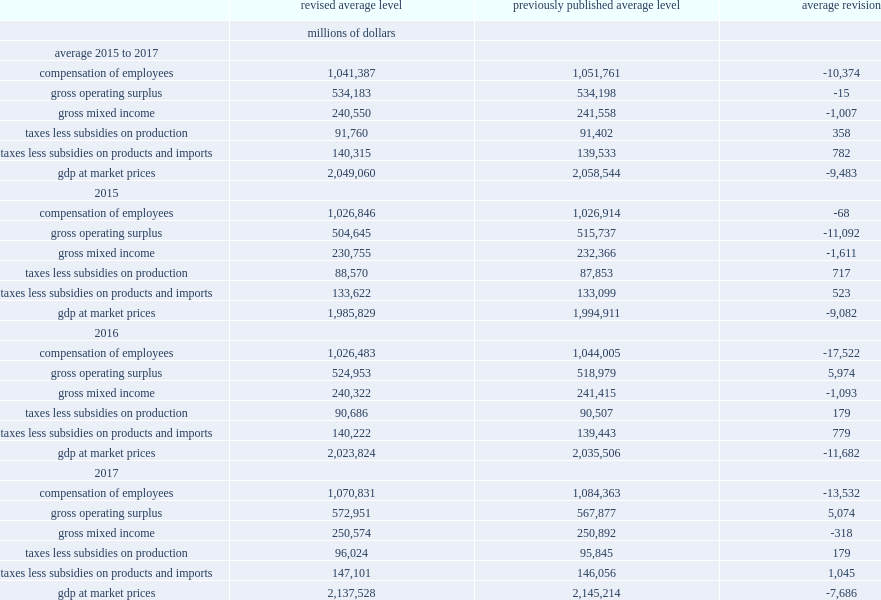Would you mind parsing the complete table? {'header': ['', 'revised average level', 'previously published average level', 'average revision'], 'rows': [['', 'millions of dollars', '', ''], ['average 2015 to 2017', '', '', ''], ['compensation of employees', '1,041,387', '1,051,761', '-10,374'], ['gross operating surplus', '534,183', '534,198', '-15'], ['gross mixed income', '240,550', '241,558', '-1,007'], ['taxes less subsidies on production', '91,760', '91,402', '358'], ['taxes less subsidies on products and imports', '140,315', '139,533', '782'], ['gdp at market prices', '2,049,060', '2,058,544', '-9,483'], ['2015', '', '', ''], ['compensation of employees', '1,026,846', '1,026,914', '-68'], ['gross operating surplus', '504,645', '515,737', '-11,092'], ['gross mixed income', '230,755', '232,366', '-1,611'], ['taxes less subsidies on production', '88,570', '87,853', '717'], ['taxes less subsidies on products and imports', '133,622', '133,099', '523'], ['gdp at market prices', '1,985,829', '1,994,911', '-9,082'], ['2016', '', '', ''], ['compensation of employees', '1,026,483', '1,044,005', '-17,522'], ['gross operating surplus', '524,953', '518,979', '5,974'], ['gross mixed income', '240,322', '241,415', '-1,093'], ['taxes less subsidies on production', '90,686', '90,507', '179'], ['taxes less subsidies on products and imports', '140,222', '139,443', '779'], ['gdp at market prices', '2,023,824', '2,035,506', '-11,682'], ['2017', '', '', ''], ['compensation of employees', '1,070,831', '1,084,363', '-13,532'], ['gross operating surplus', '572,951', '567,877', '5,074'], ['gross mixed income', '250,574', '250,892', '-318'], ['taxes less subsidies on production', '96,024', '95,845', '179'], ['taxes less subsidies on products and imports', '147,101', '146,056', '1,045'], ['gdp at market prices', '2,137,528', '2,145,214', '-7,686']]} How many millions of dollars of the value of gross operating surplus have been adjusted downward in 2015? 11092. How many millions of dollars of the value of compensation of employees have been reduced in 2016? 17522. How many millions of dollars of the value of compensation of employees have been reduced in 2017? 13532. 